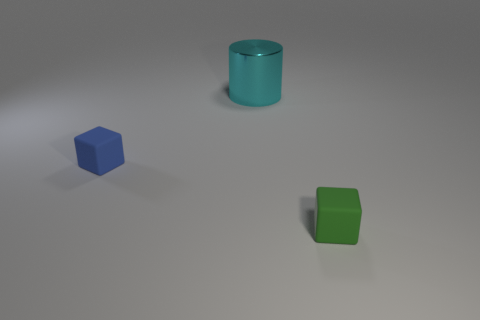Subtract all blue blocks. How many blocks are left? 1 Add 3 small green blocks. How many objects exist? 6 Subtract 0 brown cubes. How many objects are left? 3 Subtract all blocks. How many objects are left? 1 Subtract 1 cylinders. How many cylinders are left? 0 Subtract all brown blocks. Subtract all green balls. How many blocks are left? 2 Subtract all gray balls. How many brown cylinders are left? 0 Subtract all tiny purple cubes. Subtract all green rubber cubes. How many objects are left? 2 Add 1 rubber objects. How many rubber objects are left? 3 Add 3 green matte objects. How many green matte objects exist? 4 